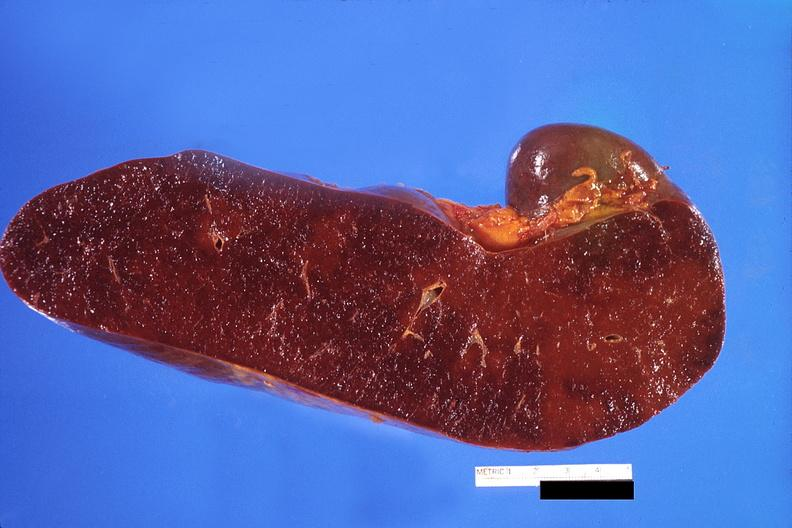s hematologic present?
Answer the question using a single word or phrase. Yes 